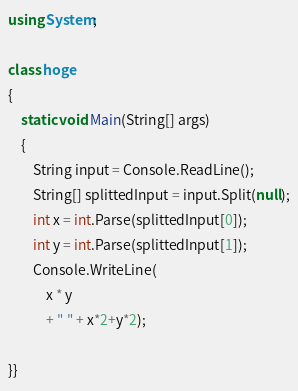Convert code to text. <code><loc_0><loc_0><loc_500><loc_500><_C#_>using System;
  
class hoge
{
    static void Main(String[] args)
    {
        String input = Console.ReadLine();
        String[] splittedInput = input.Split(null);
        int x = int.Parse(splittedInput[0]);
        int y = int.Parse(splittedInput[1]);
        Console.WriteLine(
            x * y
            + " " + x*2+y*2);
  
}}</code> 